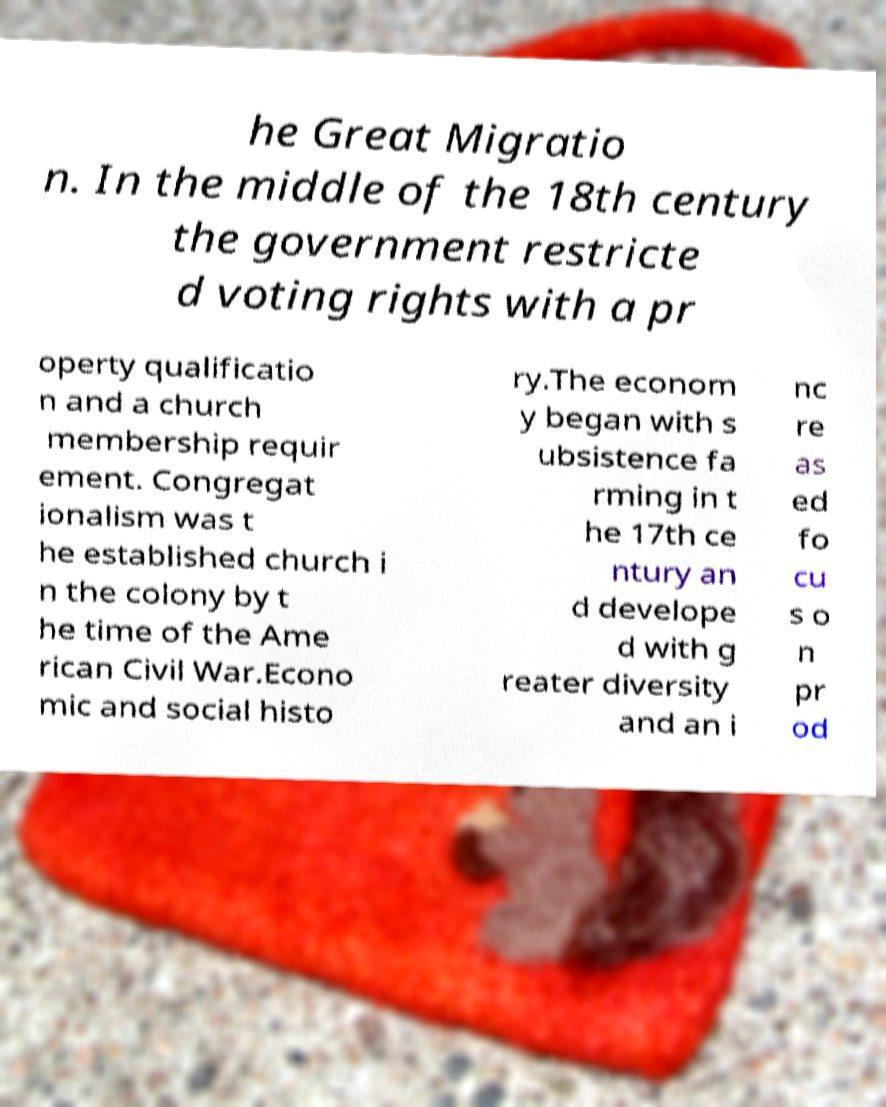For documentation purposes, I need the text within this image transcribed. Could you provide that? he Great Migratio n. In the middle of the 18th century the government restricte d voting rights with a pr operty qualificatio n and a church membership requir ement. Congregat ionalism was t he established church i n the colony by t he time of the Ame rican Civil War.Econo mic and social histo ry.The econom y began with s ubsistence fa rming in t he 17th ce ntury an d develope d with g reater diversity and an i nc re as ed fo cu s o n pr od 